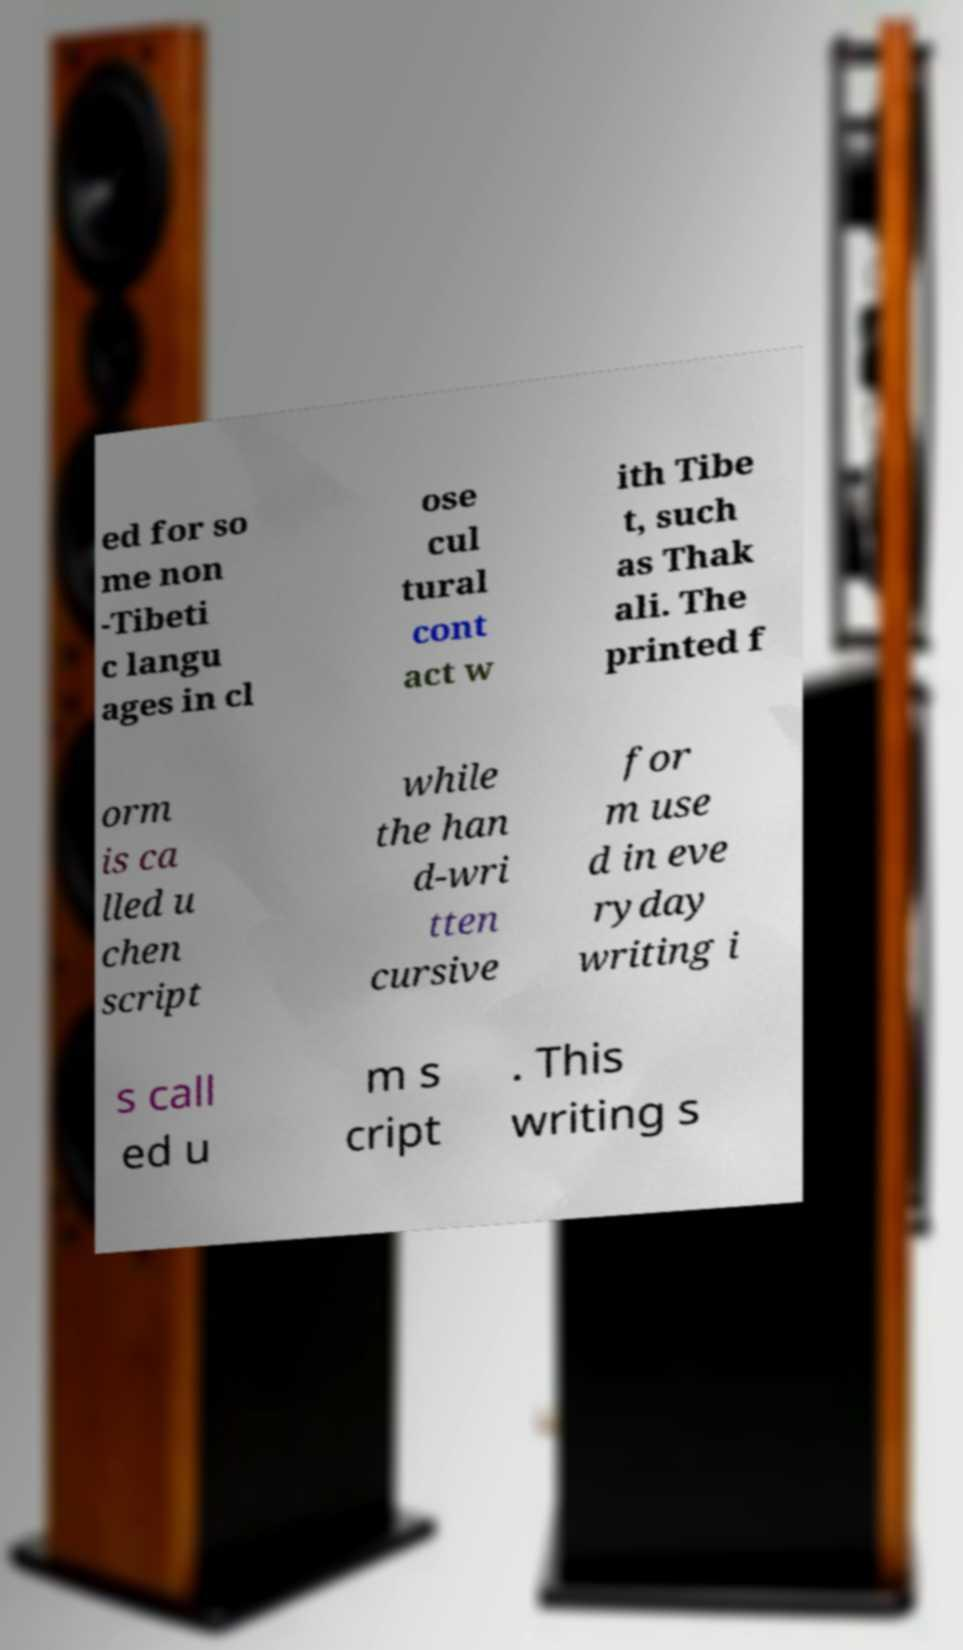I need the written content from this picture converted into text. Can you do that? ed for so me non -Tibeti c langu ages in cl ose cul tural cont act w ith Tibe t, such as Thak ali. The printed f orm is ca lled u chen script while the han d-wri tten cursive for m use d in eve ryday writing i s call ed u m s cript . This writing s 